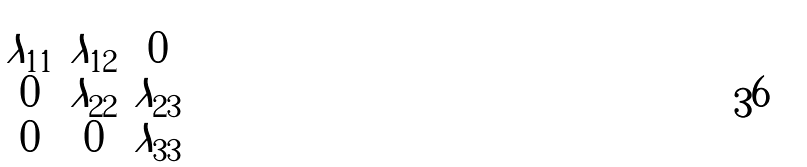Convert formula to latex. <formula><loc_0><loc_0><loc_500><loc_500>\begin{pmatrix} \lambda _ { 1 1 } & \lambda _ { 1 2 } & 0 \\ 0 & \lambda _ { 2 2 } & \lambda _ { 2 3 } \\ 0 & 0 & \lambda _ { 3 3 } \end{pmatrix}</formula> 